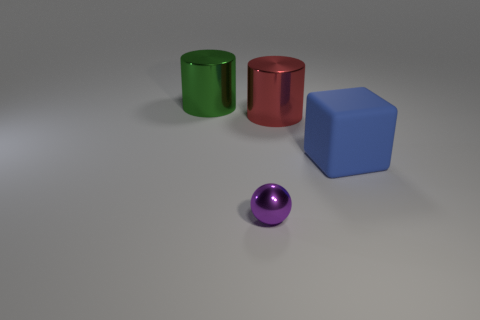Add 1 tiny metal spheres. How many objects exist? 5 Subtract all green cylinders. How many cylinders are left? 1 Subtract all big blue matte blocks. Subtract all green objects. How many objects are left? 2 Add 3 shiny cylinders. How many shiny cylinders are left? 5 Add 4 cubes. How many cubes exist? 5 Subtract 1 purple balls. How many objects are left? 3 Subtract all spheres. How many objects are left? 3 Subtract 1 balls. How many balls are left? 0 Subtract all cyan cylinders. Subtract all purple blocks. How many cylinders are left? 2 Subtract all blue spheres. How many red cylinders are left? 1 